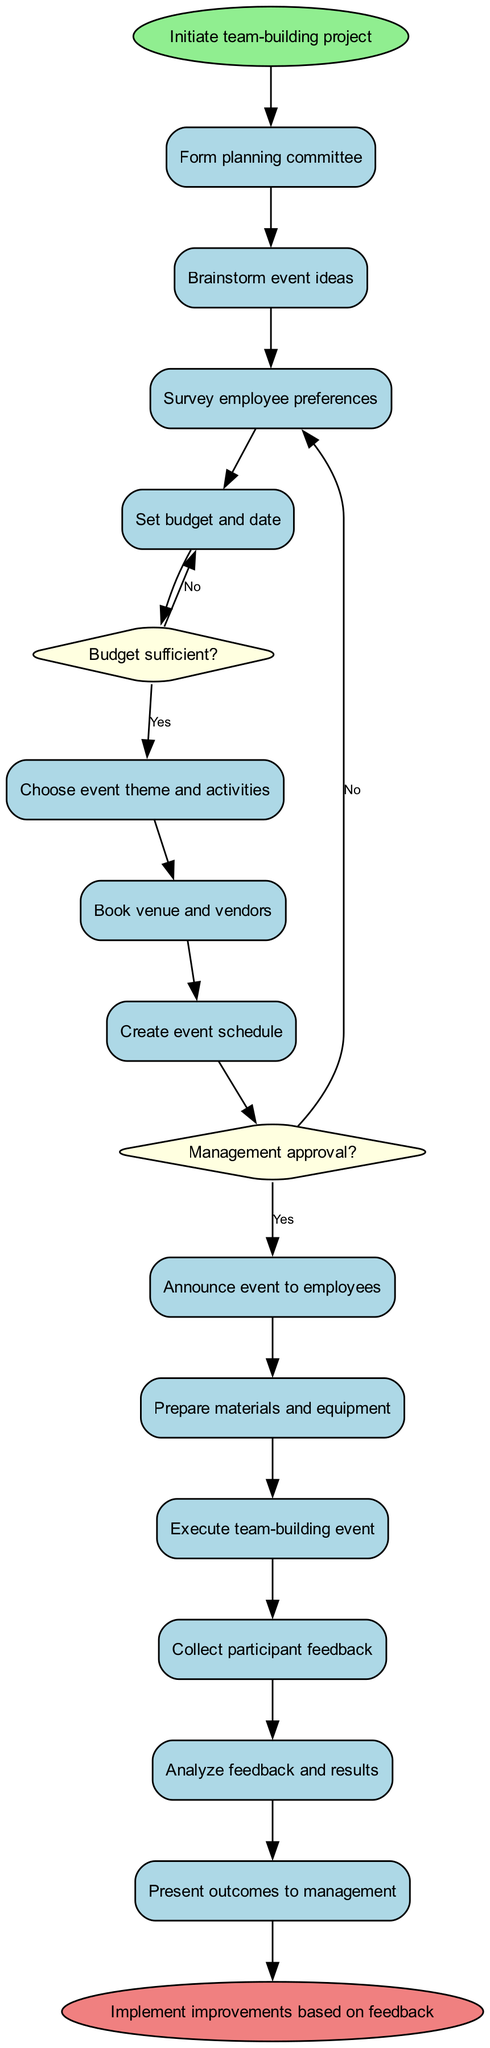What is the first activity in the diagram? The first activity is indicated directly after the "start" node in the diagram. It is labeled "Form planning committee".
Answer: Form planning committee How many decision nodes are present in the diagram? The diagram contains two decision nodes as represented by the two diamond-shaped nodes which are labeled with questions.
Answer: 2 What does the first decision node ask? The first decision node, positioned after the activity "Create event schedule", poses the question "Management approval?".
Answer: Management approval? What happens if the budget is not sufficient? Following the decision around budget sufficiency marked by the second decision node, if the budget is not sufficient (answering "No"), the flow leads back to "Adjust event scope".
Answer: Adjust event scope What is the last activity before the end of the process? The final activity node, prior to reaching the "end" node in the flow, is labeled "Present outcomes to management".
Answer: Present outcomes to management If the event date and budget are approved, how many activities are executed sequentially after that? Starting from the approved date and budget, the subsequent activities directly flow in sequence leading to the "Execute team-building event" activity. Counting these gives four activities (from "Choose event theme and activities" to "Execute team-building event").
Answer: 4 What are the two outcomes following the decision on management approval? The outcomes for the first decision node offer two paths: "Proceed with planning" if the answer is yes and "Revise proposal" if the answer is no.
Answer: Proceed with planning; Revise proposal What is the final node in this activity diagram? The last node present in the flow after all activities and processes is labeled "Implement improvements based on feedback".
Answer: Implement improvements based on feedback 